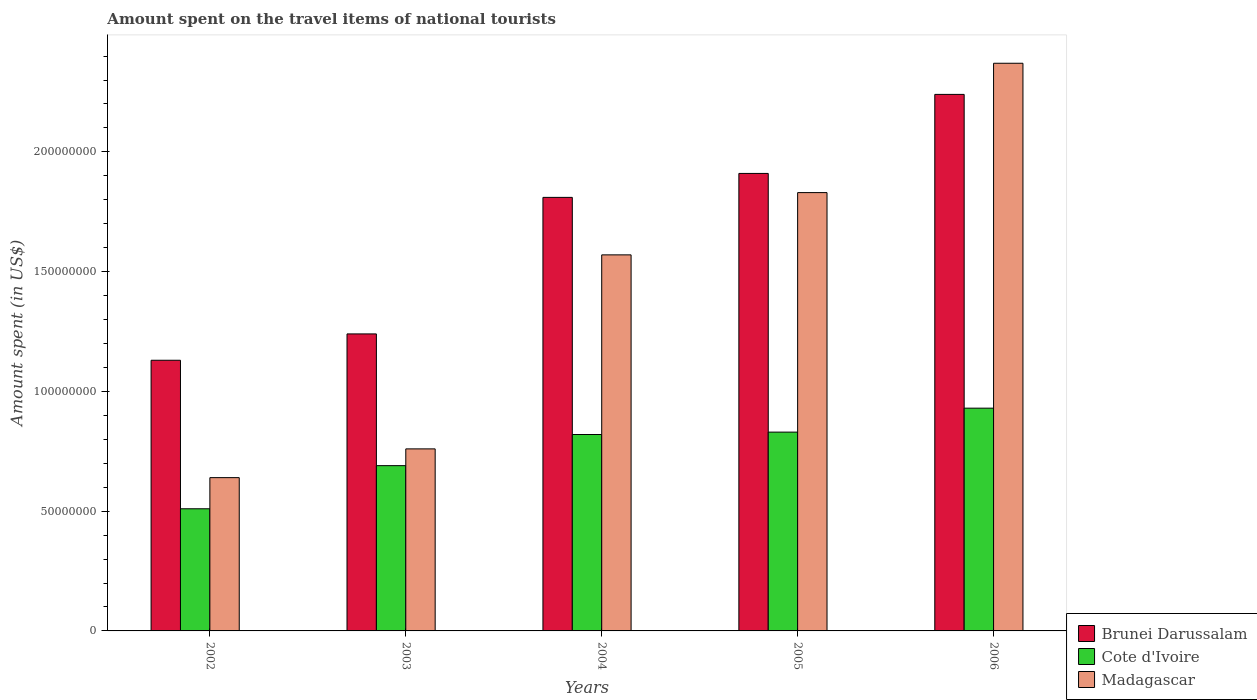How many different coloured bars are there?
Your answer should be very brief. 3. Are the number of bars per tick equal to the number of legend labels?
Ensure brevity in your answer.  Yes. How many bars are there on the 4th tick from the left?
Offer a very short reply. 3. What is the label of the 2nd group of bars from the left?
Give a very brief answer. 2003. In how many cases, is the number of bars for a given year not equal to the number of legend labels?
Provide a short and direct response. 0. What is the amount spent on the travel items of national tourists in Madagascar in 2003?
Your answer should be compact. 7.60e+07. Across all years, what is the maximum amount spent on the travel items of national tourists in Madagascar?
Provide a succinct answer. 2.37e+08. Across all years, what is the minimum amount spent on the travel items of national tourists in Madagascar?
Make the answer very short. 6.40e+07. In which year was the amount spent on the travel items of national tourists in Madagascar maximum?
Your answer should be very brief. 2006. What is the total amount spent on the travel items of national tourists in Madagascar in the graph?
Offer a terse response. 7.17e+08. What is the difference between the amount spent on the travel items of national tourists in Madagascar in 2002 and that in 2006?
Your answer should be compact. -1.73e+08. What is the difference between the amount spent on the travel items of national tourists in Brunei Darussalam in 2003 and the amount spent on the travel items of national tourists in Cote d'Ivoire in 2002?
Give a very brief answer. 7.30e+07. What is the average amount spent on the travel items of national tourists in Cote d'Ivoire per year?
Offer a terse response. 7.56e+07. In the year 2006, what is the difference between the amount spent on the travel items of national tourists in Brunei Darussalam and amount spent on the travel items of national tourists in Madagascar?
Provide a succinct answer. -1.30e+07. What is the ratio of the amount spent on the travel items of national tourists in Cote d'Ivoire in 2003 to that in 2004?
Your answer should be compact. 0.84. Is the amount spent on the travel items of national tourists in Madagascar in 2004 less than that in 2005?
Provide a succinct answer. Yes. Is the difference between the amount spent on the travel items of national tourists in Brunei Darussalam in 2004 and 2005 greater than the difference between the amount spent on the travel items of national tourists in Madagascar in 2004 and 2005?
Ensure brevity in your answer.  Yes. What is the difference between the highest and the lowest amount spent on the travel items of national tourists in Cote d'Ivoire?
Your response must be concise. 4.20e+07. In how many years, is the amount spent on the travel items of national tourists in Brunei Darussalam greater than the average amount spent on the travel items of national tourists in Brunei Darussalam taken over all years?
Provide a succinct answer. 3. Is the sum of the amount spent on the travel items of national tourists in Madagascar in 2005 and 2006 greater than the maximum amount spent on the travel items of national tourists in Cote d'Ivoire across all years?
Ensure brevity in your answer.  Yes. What does the 1st bar from the left in 2002 represents?
Provide a short and direct response. Brunei Darussalam. What does the 2nd bar from the right in 2003 represents?
Offer a very short reply. Cote d'Ivoire. Is it the case that in every year, the sum of the amount spent on the travel items of national tourists in Madagascar and amount spent on the travel items of national tourists in Cote d'Ivoire is greater than the amount spent on the travel items of national tourists in Brunei Darussalam?
Make the answer very short. Yes. How many years are there in the graph?
Keep it short and to the point. 5. Are the values on the major ticks of Y-axis written in scientific E-notation?
Provide a succinct answer. No. Does the graph contain grids?
Provide a short and direct response. No. Where does the legend appear in the graph?
Your response must be concise. Bottom right. How many legend labels are there?
Provide a short and direct response. 3. How are the legend labels stacked?
Offer a terse response. Vertical. What is the title of the graph?
Your answer should be very brief. Amount spent on the travel items of national tourists. Does "Arab World" appear as one of the legend labels in the graph?
Keep it short and to the point. No. What is the label or title of the Y-axis?
Provide a short and direct response. Amount spent (in US$). What is the Amount spent (in US$) of Brunei Darussalam in 2002?
Offer a very short reply. 1.13e+08. What is the Amount spent (in US$) in Cote d'Ivoire in 2002?
Provide a succinct answer. 5.10e+07. What is the Amount spent (in US$) in Madagascar in 2002?
Ensure brevity in your answer.  6.40e+07. What is the Amount spent (in US$) of Brunei Darussalam in 2003?
Make the answer very short. 1.24e+08. What is the Amount spent (in US$) in Cote d'Ivoire in 2003?
Your answer should be very brief. 6.90e+07. What is the Amount spent (in US$) in Madagascar in 2003?
Provide a short and direct response. 7.60e+07. What is the Amount spent (in US$) in Brunei Darussalam in 2004?
Your response must be concise. 1.81e+08. What is the Amount spent (in US$) of Cote d'Ivoire in 2004?
Make the answer very short. 8.20e+07. What is the Amount spent (in US$) in Madagascar in 2004?
Keep it short and to the point. 1.57e+08. What is the Amount spent (in US$) of Brunei Darussalam in 2005?
Your answer should be compact. 1.91e+08. What is the Amount spent (in US$) in Cote d'Ivoire in 2005?
Ensure brevity in your answer.  8.30e+07. What is the Amount spent (in US$) of Madagascar in 2005?
Provide a succinct answer. 1.83e+08. What is the Amount spent (in US$) of Brunei Darussalam in 2006?
Offer a terse response. 2.24e+08. What is the Amount spent (in US$) in Cote d'Ivoire in 2006?
Your answer should be compact. 9.30e+07. What is the Amount spent (in US$) in Madagascar in 2006?
Offer a terse response. 2.37e+08. Across all years, what is the maximum Amount spent (in US$) in Brunei Darussalam?
Offer a very short reply. 2.24e+08. Across all years, what is the maximum Amount spent (in US$) of Cote d'Ivoire?
Keep it short and to the point. 9.30e+07. Across all years, what is the maximum Amount spent (in US$) in Madagascar?
Offer a terse response. 2.37e+08. Across all years, what is the minimum Amount spent (in US$) in Brunei Darussalam?
Make the answer very short. 1.13e+08. Across all years, what is the minimum Amount spent (in US$) of Cote d'Ivoire?
Provide a succinct answer. 5.10e+07. Across all years, what is the minimum Amount spent (in US$) of Madagascar?
Your answer should be very brief. 6.40e+07. What is the total Amount spent (in US$) of Brunei Darussalam in the graph?
Keep it short and to the point. 8.33e+08. What is the total Amount spent (in US$) of Cote d'Ivoire in the graph?
Make the answer very short. 3.78e+08. What is the total Amount spent (in US$) of Madagascar in the graph?
Offer a very short reply. 7.17e+08. What is the difference between the Amount spent (in US$) in Brunei Darussalam in 2002 and that in 2003?
Offer a very short reply. -1.10e+07. What is the difference between the Amount spent (in US$) of Cote d'Ivoire in 2002 and that in 2003?
Keep it short and to the point. -1.80e+07. What is the difference between the Amount spent (in US$) of Madagascar in 2002 and that in 2003?
Keep it short and to the point. -1.20e+07. What is the difference between the Amount spent (in US$) in Brunei Darussalam in 2002 and that in 2004?
Your answer should be very brief. -6.80e+07. What is the difference between the Amount spent (in US$) in Cote d'Ivoire in 2002 and that in 2004?
Offer a terse response. -3.10e+07. What is the difference between the Amount spent (in US$) in Madagascar in 2002 and that in 2004?
Ensure brevity in your answer.  -9.30e+07. What is the difference between the Amount spent (in US$) of Brunei Darussalam in 2002 and that in 2005?
Provide a short and direct response. -7.80e+07. What is the difference between the Amount spent (in US$) of Cote d'Ivoire in 2002 and that in 2005?
Your answer should be very brief. -3.20e+07. What is the difference between the Amount spent (in US$) in Madagascar in 2002 and that in 2005?
Provide a succinct answer. -1.19e+08. What is the difference between the Amount spent (in US$) in Brunei Darussalam in 2002 and that in 2006?
Provide a succinct answer. -1.11e+08. What is the difference between the Amount spent (in US$) of Cote d'Ivoire in 2002 and that in 2006?
Your answer should be very brief. -4.20e+07. What is the difference between the Amount spent (in US$) in Madagascar in 2002 and that in 2006?
Offer a terse response. -1.73e+08. What is the difference between the Amount spent (in US$) in Brunei Darussalam in 2003 and that in 2004?
Keep it short and to the point. -5.70e+07. What is the difference between the Amount spent (in US$) of Cote d'Ivoire in 2003 and that in 2004?
Your response must be concise. -1.30e+07. What is the difference between the Amount spent (in US$) of Madagascar in 2003 and that in 2004?
Give a very brief answer. -8.10e+07. What is the difference between the Amount spent (in US$) in Brunei Darussalam in 2003 and that in 2005?
Offer a very short reply. -6.70e+07. What is the difference between the Amount spent (in US$) of Cote d'Ivoire in 2003 and that in 2005?
Provide a succinct answer. -1.40e+07. What is the difference between the Amount spent (in US$) in Madagascar in 2003 and that in 2005?
Provide a succinct answer. -1.07e+08. What is the difference between the Amount spent (in US$) in Brunei Darussalam in 2003 and that in 2006?
Your answer should be compact. -1.00e+08. What is the difference between the Amount spent (in US$) of Cote d'Ivoire in 2003 and that in 2006?
Your response must be concise. -2.40e+07. What is the difference between the Amount spent (in US$) of Madagascar in 2003 and that in 2006?
Your answer should be compact. -1.61e+08. What is the difference between the Amount spent (in US$) in Brunei Darussalam in 2004 and that in 2005?
Offer a very short reply. -1.00e+07. What is the difference between the Amount spent (in US$) of Cote d'Ivoire in 2004 and that in 2005?
Provide a succinct answer. -1.00e+06. What is the difference between the Amount spent (in US$) in Madagascar in 2004 and that in 2005?
Your answer should be compact. -2.60e+07. What is the difference between the Amount spent (in US$) of Brunei Darussalam in 2004 and that in 2006?
Offer a terse response. -4.30e+07. What is the difference between the Amount spent (in US$) in Cote d'Ivoire in 2004 and that in 2006?
Offer a very short reply. -1.10e+07. What is the difference between the Amount spent (in US$) of Madagascar in 2004 and that in 2006?
Make the answer very short. -8.00e+07. What is the difference between the Amount spent (in US$) in Brunei Darussalam in 2005 and that in 2006?
Give a very brief answer. -3.30e+07. What is the difference between the Amount spent (in US$) in Cote d'Ivoire in 2005 and that in 2006?
Make the answer very short. -1.00e+07. What is the difference between the Amount spent (in US$) in Madagascar in 2005 and that in 2006?
Give a very brief answer. -5.40e+07. What is the difference between the Amount spent (in US$) of Brunei Darussalam in 2002 and the Amount spent (in US$) of Cote d'Ivoire in 2003?
Your response must be concise. 4.40e+07. What is the difference between the Amount spent (in US$) in Brunei Darussalam in 2002 and the Amount spent (in US$) in Madagascar in 2003?
Provide a short and direct response. 3.70e+07. What is the difference between the Amount spent (in US$) in Cote d'Ivoire in 2002 and the Amount spent (in US$) in Madagascar in 2003?
Offer a terse response. -2.50e+07. What is the difference between the Amount spent (in US$) in Brunei Darussalam in 2002 and the Amount spent (in US$) in Cote d'Ivoire in 2004?
Offer a very short reply. 3.10e+07. What is the difference between the Amount spent (in US$) in Brunei Darussalam in 2002 and the Amount spent (in US$) in Madagascar in 2004?
Your answer should be compact. -4.40e+07. What is the difference between the Amount spent (in US$) of Cote d'Ivoire in 2002 and the Amount spent (in US$) of Madagascar in 2004?
Your answer should be compact. -1.06e+08. What is the difference between the Amount spent (in US$) in Brunei Darussalam in 2002 and the Amount spent (in US$) in Cote d'Ivoire in 2005?
Offer a terse response. 3.00e+07. What is the difference between the Amount spent (in US$) of Brunei Darussalam in 2002 and the Amount spent (in US$) of Madagascar in 2005?
Provide a succinct answer. -7.00e+07. What is the difference between the Amount spent (in US$) of Cote d'Ivoire in 2002 and the Amount spent (in US$) of Madagascar in 2005?
Provide a short and direct response. -1.32e+08. What is the difference between the Amount spent (in US$) of Brunei Darussalam in 2002 and the Amount spent (in US$) of Madagascar in 2006?
Keep it short and to the point. -1.24e+08. What is the difference between the Amount spent (in US$) in Cote d'Ivoire in 2002 and the Amount spent (in US$) in Madagascar in 2006?
Make the answer very short. -1.86e+08. What is the difference between the Amount spent (in US$) of Brunei Darussalam in 2003 and the Amount spent (in US$) of Cote d'Ivoire in 2004?
Ensure brevity in your answer.  4.20e+07. What is the difference between the Amount spent (in US$) of Brunei Darussalam in 2003 and the Amount spent (in US$) of Madagascar in 2004?
Make the answer very short. -3.30e+07. What is the difference between the Amount spent (in US$) in Cote d'Ivoire in 2003 and the Amount spent (in US$) in Madagascar in 2004?
Provide a short and direct response. -8.80e+07. What is the difference between the Amount spent (in US$) in Brunei Darussalam in 2003 and the Amount spent (in US$) in Cote d'Ivoire in 2005?
Your answer should be compact. 4.10e+07. What is the difference between the Amount spent (in US$) in Brunei Darussalam in 2003 and the Amount spent (in US$) in Madagascar in 2005?
Offer a very short reply. -5.90e+07. What is the difference between the Amount spent (in US$) in Cote d'Ivoire in 2003 and the Amount spent (in US$) in Madagascar in 2005?
Offer a terse response. -1.14e+08. What is the difference between the Amount spent (in US$) in Brunei Darussalam in 2003 and the Amount spent (in US$) in Cote d'Ivoire in 2006?
Provide a short and direct response. 3.10e+07. What is the difference between the Amount spent (in US$) in Brunei Darussalam in 2003 and the Amount spent (in US$) in Madagascar in 2006?
Keep it short and to the point. -1.13e+08. What is the difference between the Amount spent (in US$) in Cote d'Ivoire in 2003 and the Amount spent (in US$) in Madagascar in 2006?
Provide a succinct answer. -1.68e+08. What is the difference between the Amount spent (in US$) in Brunei Darussalam in 2004 and the Amount spent (in US$) in Cote d'Ivoire in 2005?
Offer a very short reply. 9.80e+07. What is the difference between the Amount spent (in US$) of Brunei Darussalam in 2004 and the Amount spent (in US$) of Madagascar in 2005?
Provide a succinct answer. -2.00e+06. What is the difference between the Amount spent (in US$) in Cote d'Ivoire in 2004 and the Amount spent (in US$) in Madagascar in 2005?
Offer a terse response. -1.01e+08. What is the difference between the Amount spent (in US$) of Brunei Darussalam in 2004 and the Amount spent (in US$) of Cote d'Ivoire in 2006?
Your answer should be very brief. 8.80e+07. What is the difference between the Amount spent (in US$) of Brunei Darussalam in 2004 and the Amount spent (in US$) of Madagascar in 2006?
Ensure brevity in your answer.  -5.60e+07. What is the difference between the Amount spent (in US$) of Cote d'Ivoire in 2004 and the Amount spent (in US$) of Madagascar in 2006?
Ensure brevity in your answer.  -1.55e+08. What is the difference between the Amount spent (in US$) in Brunei Darussalam in 2005 and the Amount spent (in US$) in Cote d'Ivoire in 2006?
Your response must be concise. 9.80e+07. What is the difference between the Amount spent (in US$) in Brunei Darussalam in 2005 and the Amount spent (in US$) in Madagascar in 2006?
Ensure brevity in your answer.  -4.60e+07. What is the difference between the Amount spent (in US$) of Cote d'Ivoire in 2005 and the Amount spent (in US$) of Madagascar in 2006?
Offer a terse response. -1.54e+08. What is the average Amount spent (in US$) in Brunei Darussalam per year?
Offer a terse response. 1.67e+08. What is the average Amount spent (in US$) of Cote d'Ivoire per year?
Your answer should be very brief. 7.56e+07. What is the average Amount spent (in US$) in Madagascar per year?
Your answer should be very brief. 1.43e+08. In the year 2002, what is the difference between the Amount spent (in US$) of Brunei Darussalam and Amount spent (in US$) of Cote d'Ivoire?
Offer a very short reply. 6.20e+07. In the year 2002, what is the difference between the Amount spent (in US$) in Brunei Darussalam and Amount spent (in US$) in Madagascar?
Provide a short and direct response. 4.90e+07. In the year 2002, what is the difference between the Amount spent (in US$) of Cote d'Ivoire and Amount spent (in US$) of Madagascar?
Provide a succinct answer. -1.30e+07. In the year 2003, what is the difference between the Amount spent (in US$) of Brunei Darussalam and Amount spent (in US$) of Cote d'Ivoire?
Your answer should be compact. 5.50e+07. In the year 2003, what is the difference between the Amount spent (in US$) of Brunei Darussalam and Amount spent (in US$) of Madagascar?
Ensure brevity in your answer.  4.80e+07. In the year 2003, what is the difference between the Amount spent (in US$) in Cote d'Ivoire and Amount spent (in US$) in Madagascar?
Provide a succinct answer. -7.00e+06. In the year 2004, what is the difference between the Amount spent (in US$) of Brunei Darussalam and Amount spent (in US$) of Cote d'Ivoire?
Provide a short and direct response. 9.90e+07. In the year 2004, what is the difference between the Amount spent (in US$) of Brunei Darussalam and Amount spent (in US$) of Madagascar?
Offer a very short reply. 2.40e+07. In the year 2004, what is the difference between the Amount spent (in US$) of Cote d'Ivoire and Amount spent (in US$) of Madagascar?
Your response must be concise. -7.50e+07. In the year 2005, what is the difference between the Amount spent (in US$) in Brunei Darussalam and Amount spent (in US$) in Cote d'Ivoire?
Offer a terse response. 1.08e+08. In the year 2005, what is the difference between the Amount spent (in US$) in Brunei Darussalam and Amount spent (in US$) in Madagascar?
Keep it short and to the point. 8.00e+06. In the year 2005, what is the difference between the Amount spent (in US$) of Cote d'Ivoire and Amount spent (in US$) of Madagascar?
Your answer should be compact. -1.00e+08. In the year 2006, what is the difference between the Amount spent (in US$) in Brunei Darussalam and Amount spent (in US$) in Cote d'Ivoire?
Offer a very short reply. 1.31e+08. In the year 2006, what is the difference between the Amount spent (in US$) in Brunei Darussalam and Amount spent (in US$) in Madagascar?
Your answer should be compact. -1.30e+07. In the year 2006, what is the difference between the Amount spent (in US$) in Cote d'Ivoire and Amount spent (in US$) in Madagascar?
Keep it short and to the point. -1.44e+08. What is the ratio of the Amount spent (in US$) in Brunei Darussalam in 2002 to that in 2003?
Make the answer very short. 0.91. What is the ratio of the Amount spent (in US$) of Cote d'Ivoire in 2002 to that in 2003?
Ensure brevity in your answer.  0.74. What is the ratio of the Amount spent (in US$) of Madagascar in 2002 to that in 2003?
Provide a short and direct response. 0.84. What is the ratio of the Amount spent (in US$) in Brunei Darussalam in 2002 to that in 2004?
Provide a short and direct response. 0.62. What is the ratio of the Amount spent (in US$) of Cote d'Ivoire in 2002 to that in 2004?
Offer a terse response. 0.62. What is the ratio of the Amount spent (in US$) of Madagascar in 2002 to that in 2004?
Provide a short and direct response. 0.41. What is the ratio of the Amount spent (in US$) in Brunei Darussalam in 2002 to that in 2005?
Ensure brevity in your answer.  0.59. What is the ratio of the Amount spent (in US$) in Cote d'Ivoire in 2002 to that in 2005?
Keep it short and to the point. 0.61. What is the ratio of the Amount spent (in US$) in Madagascar in 2002 to that in 2005?
Give a very brief answer. 0.35. What is the ratio of the Amount spent (in US$) in Brunei Darussalam in 2002 to that in 2006?
Keep it short and to the point. 0.5. What is the ratio of the Amount spent (in US$) of Cote d'Ivoire in 2002 to that in 2006?
Provide a succinct answer. 0.55. What is the ratio of the Amount spent (in US$) of Madagascar in 2002 to that in 2006?
Your answer should be compact. 0.27. What is the ratio of the Amount spent (in US$) in Brunei Darussalam in 2003 to that in 2004?
Provide a succinct answer. 0.69. What is the ratio of the Amount spent (in US$) of Cote d'Ivoire in 2003 to that in 2004?
Offer a terse response. 0.84. What is the ratio of the Amount spent (in US$) of Madagascar in 2003 to that in 2004?
Make the answer very short. 0.48. What is the ratio of the Amount spent (in US$) in Brunei Darussalam in 2003 to that in 2005?
Give a very brief answer. 0.65. What is the ratio of the Amount spent (in US$) in Cote d'Ivoire in 2003 to that in 2005?
Your answer should be compact. 0.83. What is the ratio of the Amount spent (in US$) in Madagascar in 2003 to that in 2005?
Keep it short and to the point. 0.42. What is the ratio of the Amount spent (in US$) in Brunei Darussalam in 2003 to that in 2006?
Ensure brevity in your answer.  0.55. What is the ratio of the Amount spent (in US$) of Cote d'Ivoire in 2003 to that in 2006?
Provide a short and direct response. 0.74. What is the ratio of the Amount spent (in US$) of Madagascar in 2003 to that in 2006?
Ensure brevity in your answer.  0.32. What is the ratio of the Amount spent (in US$) in Brunei Darussalam in 2004 to that in 2005?
Provide a short and direct response. 0.95. What is the ratio of the Amount spent (in US$) in Madagascar in 2004 to that in 2005?
Make the answer very short. 0.86. What is the ratio of the Amount spent (in US$) of Brunei Darussalam in 2004 to that in 2006?
Offer a terse response. 0.81. What is the ratio of the Amount spent (in US$) of Cote d'Ivoire in 2004 to that in 2006?
Give a very brief answer. 0.88. What is the ratio of the Amount spent (in US$) of Madagascar in 2004 to that in 2006?
Your answer should be compact. 0.66. What is the ratio of the Amount spent (in US$) in Brunei Darussalam in 2005 to that in 2006?
Offer a terse response. 0.85. What is the ratio of the Amount spent (in US$) in Cote d'Ivoire in 2005 to that in 2006?
Your response must be concise. 0.89. What is the ratio of the Amount spent (in US$) in Madagascar in 2005 to that in 2006?
Keep it short and to the point. 0.77. What is the difference between the highest and the second highest Amount spent (in US$) of Brunei Darussalam?
Give a very brief answer. 3.30e+07. What is the difference between the highest and the second highest Amount spent (in US$) in Madagascar?
Your answer should be very brief. 5.40e+07. What is the difference between the highest and the lowest Amount spent (in US$) of Brunei Darussalam?
Offer a very short reply. 1.11e+08. What is the difference between the highest and the lowest Amount spent (in US$) in Cote d'Ivoire?
Provide a short and direct response. 4.20e+07. What is the difference between the highest and the lowest Amount spent (in US$) of Madagascar?
Ensure brevity in your answer.  1.73e+08. 